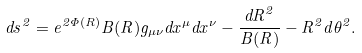Convert formula to latex. <formula><loc_0><loc_0><loc_500><loc_500>d s ^ { 2 } = e ^ { 2 \Phi ( R ) } B ( R ) g _ { \mu \nu } d x ^ { \mu } d x ^ { \nu } - \frac { { d R } ^ { 2 } } { B ( R ) } - R ^ { 2 } d \theta ^ { 2 } .</formula> 